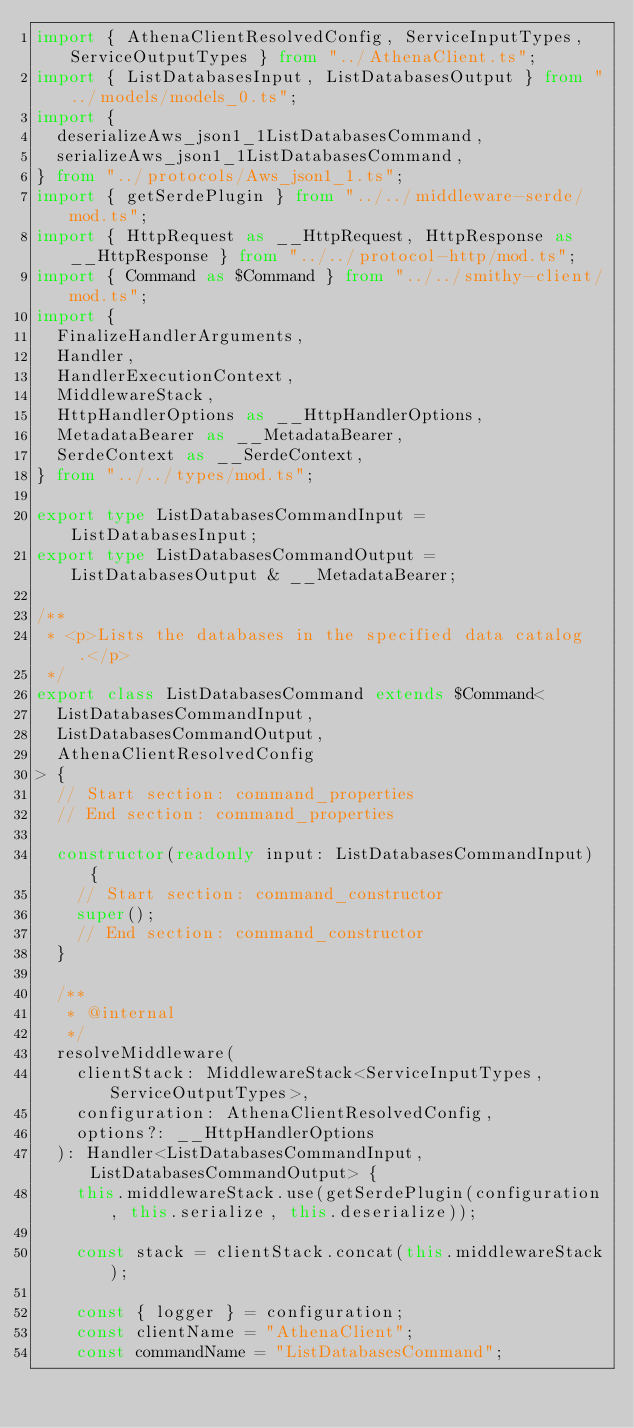<code> <loc_0><loc_0><loc_500><loc_500><_TypeScript_>import { AthenaClientResolvedConfig, ServiceInputTypes, ServiceOutputTypes } from "../AthenaClient.ts";
import { ListDatabasesInput, ListDatabasesOutput } from "../models/models_0.ts";
import {
  deserializeAws_json1_1ListDatabasesCommand,
  serializeAws_json1_1ListDatabasesCommand,
} from "../protocols/Aws_json1_1.ts";
import { getSerdePlugin } from "../../middleware-serde/mod.ts";
import { HttpRequest as __HttpRequest, HttpResponse as __HttpResponse } from "../../protocol-http/mod.ts";
import { Command as $Command } from "../../smithy-client/mod.ts";
import {
  FinalizeHandlerArguments,
  Handler,
  HandlerExecutionContext,
  MiddlewareStack,
  HttpHandlerOptions as __HttpHandlerOptions,
  MetadataBearer as __MetadataBearer,
  SerdeContext as __SerdeContext,
} from "../../types/mod.ts";

export type ListDatabasesCommandInput = ListDatabasesInput;
export type ListDatabasesCommandOutput = ListDatabasesOutput & __MetadataBearer;

/**
 * <p>Lists the databases in the specified data catalog.</p>
 */
export class ListDatabasesCommand extends $Command<
  ListDatabasesCommandInput,
  ListDatabasesCommandOutput,
  AthenaClientResolvedConfig
> {
  // Start section: command_properties
  // End section: command_properties

  constructor(readonly input: ListDatabasesCommandInput) {
    // Start section: command_constructor
    super();
    // End section: command_constructor
  }

  /**
   * @internal
   */
  resolveMiddleware(
    clientStack: MiddlewareStack<ServiceInputTypes, ServiceOutputTypes>,
    configuration: AthenaClientResolvedConfig,
    options?: __HttpHandlerOptions
  ): Handler<ListDatabasesCommandInput, ListDatabasesCommandOutput> {
    this.middlewareStack.use(getSerdePlugin(configuration, this.serialize, this.deserialize));

    const stack = clientStack.concat(this.middlewareStack);

    const { logger } = configuration;
    const clientName = "AthenaClient";
    const commandName = "ListDatabasesCommand";</code> 